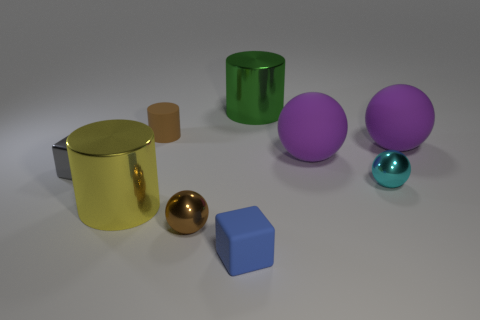There is a large green object that is made of the same material as the cyan sphere; what is its shape?
Offer a terse response. Cylinder. What number of other things are there of the same shape as the big yellow metal thing?
Your response must be concise. 2. What number of brown objects are cylinders or small rubber cylinders?
Your response must be concise. 1. Does the small gray shiny thing have the same shape as the small brown metallic object?
Provide a short and direct response. No. Is there a small blue block that is behind the small brown cylinder behind the small gray metal cube?
Provide a succinct answer. No. Is the number of cyan objects that are to the left of the small metal cube the same as the number of brown balls?
Your answer should be very brief. No. What number of other objects are the same size as the brown cylinder?
Provide a short and direct response. 4. Do the small gray block in front of the large green object and the tiny ball that is on the right side of the small blue thing have the same material?
Make the answer very short. Yes. There is a cyan thing that is to the right of the small brown thing in front of the gray metallic block; what size is it?
Give a very brief answer. Small. Are there any other cylinders of the same color as the small cylinder?
Provide a succinct answer. No. 